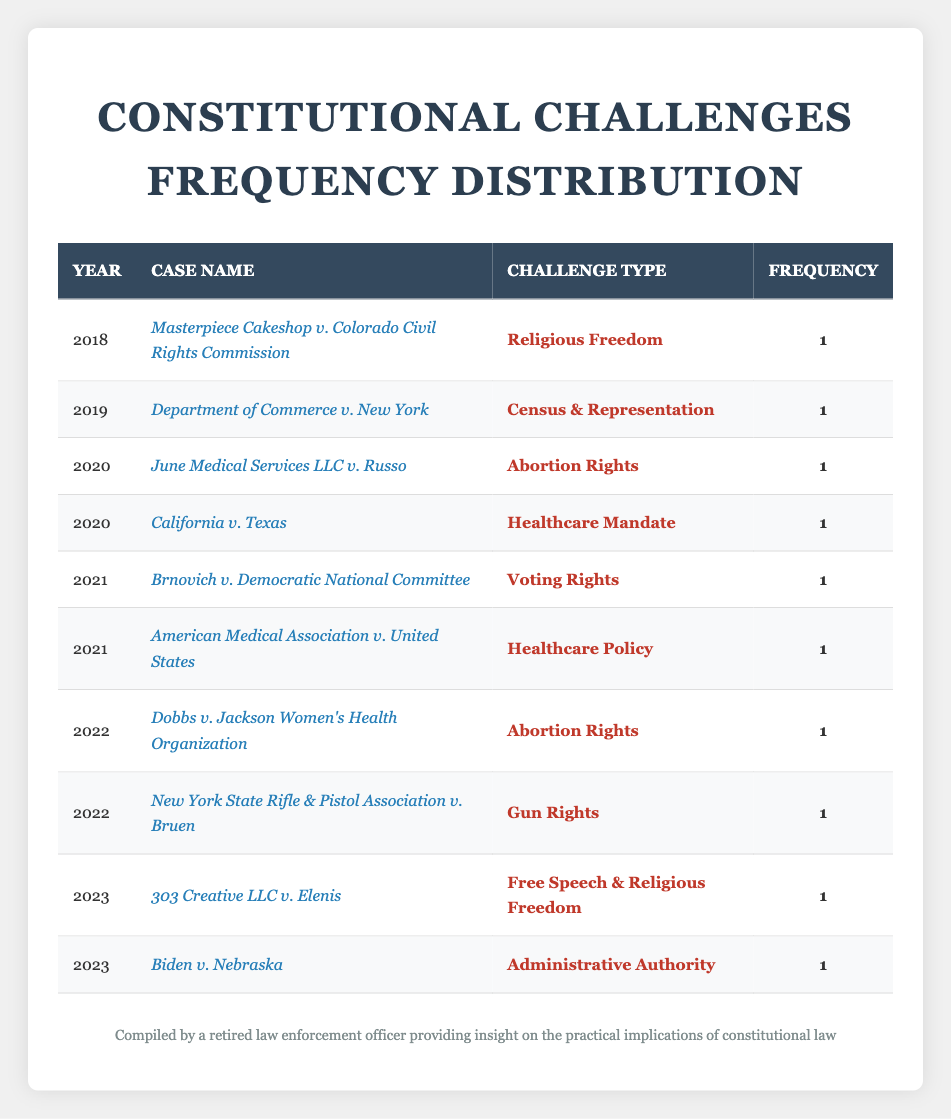What year did the case "Brnovich v. Democratic National Committee" occur? The table lists the case under the year column, which shows it falls under the year 2021.
Answer: 2021 How many cases related to "Abortion Rights" are in the table? There are two cases in the table under the challenge type "Abortion Rights": "June Medical Services LLC v. Russo" from 2020 and "Dobbs v. Jackson Women’s Health Organization" from 2022.
Answer: 2 Which challenge type was addressed in the year 2019? Referring to the year 2019 in the table, the case listed is "Department of Commerce v. New York," which falls under the challenge type "Census & Representation."
Answer: Census & Representation Is there a case challenging "Gun Rights" in the table? Yes, the table includes a case titled "New York State Rifle & Pistol Association v. Bruen," which falls under the challenge type "Gun Rights."
Answer: Yes What is the total number of cases listed in the table? By counting each row in the table, we find a total of 10 cases listed, each represented by a distinct row.
Answer: 10 How many different challenge types are represented in the table? Examining the challenge type column, we see 8 unique challenge types: Religious Freedom, Census & Representation, Abortion Rights, Healthcare Mandate, Voting Rights, Healthcare Policy, Gun Rights, and Free Speech & Religious Freedom.
Answer: 8 In which year did the most recent constitutional challenge occur according to this table? The most recent year listed in the table is 2023, where the cases "303 Creative LLC v. Elenis" and "Biden v. Nebraska" occurred.
Answer: 2023 Which case challenged "Administrative Authority" and in what year? The table shows that the case "Biden v. Nebraska" is associated with the challenge type "Administrative Authority," and it occurred in the year 2023.
Answer: Biden v. Nebraska in 2023 How many cases feature the challenge type "Healthcare Mandate" or "Healthcare Policy"? The table shows there is 1 case for "Healthcare Mandate" (California v. Texas) and 1 case for "Healthcare Policy" (American Medical Association v. United States), thus totaling 2 cases.
Answer: 2 